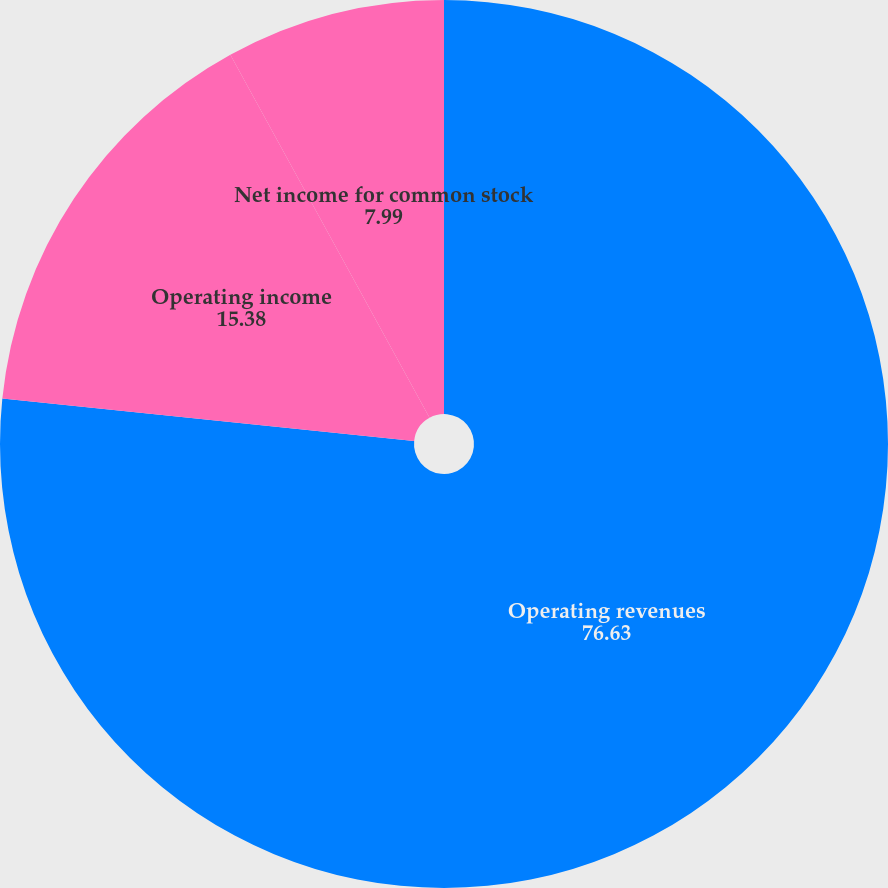<chart> <loc_0><loc_0><loc_500><loc_500><pie_chart><fcel>Operating revenues<fcel>Operating income<fcel>Net income for common stock<nl><fcel>76.63%<fcel>15.38%<fcel>7.99%<nl></chart> 